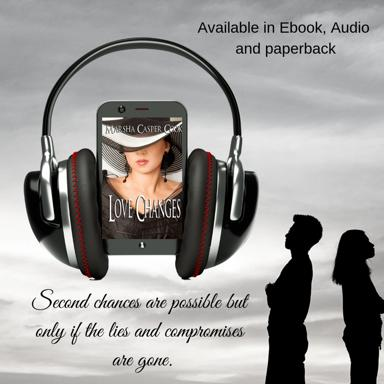What are the available formats of the content mentioned in the image? The content is available in Ebook, Audio, and paperback formats. Who is the author of the content mentioned in the image? The author is Sha Casper. What is the main idea expressed about second chances in the text? The main idea is that second chances are possible but only if the lies and compromises are gone. 